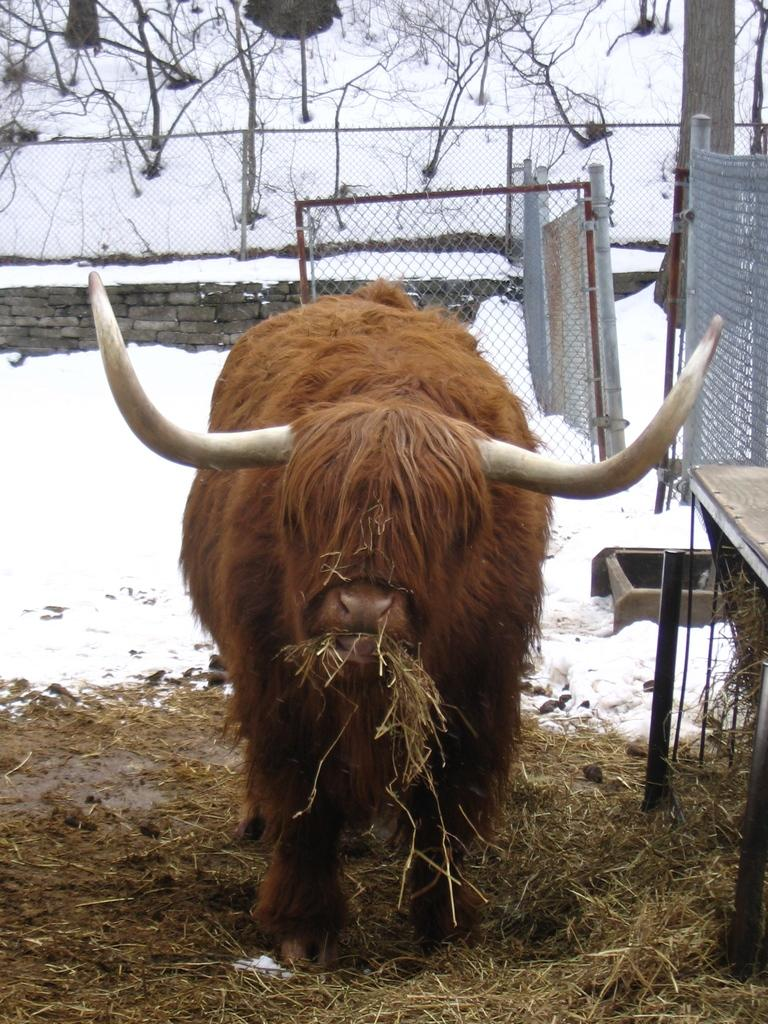What type of animal is on the ground in the image? The specific type of animal cannot be determined from the image. What is located next to the animal? There is a table beside the animal. What is the weather like in the image? The presence of snow suggests a cold or wintery environment. What can be seen in the background of the image? There is a wall, a fence, a gate, and trees in the background of the image. How many frogs are jumping in the rainstorm in the image? There is no rainstorm or frogs present in the image. 